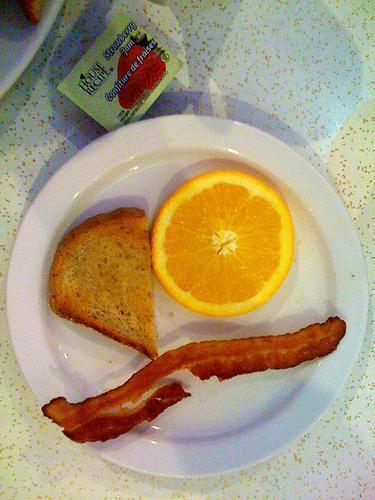How many slices of bacon are on the plate?
Give a very brief answer. 1. 